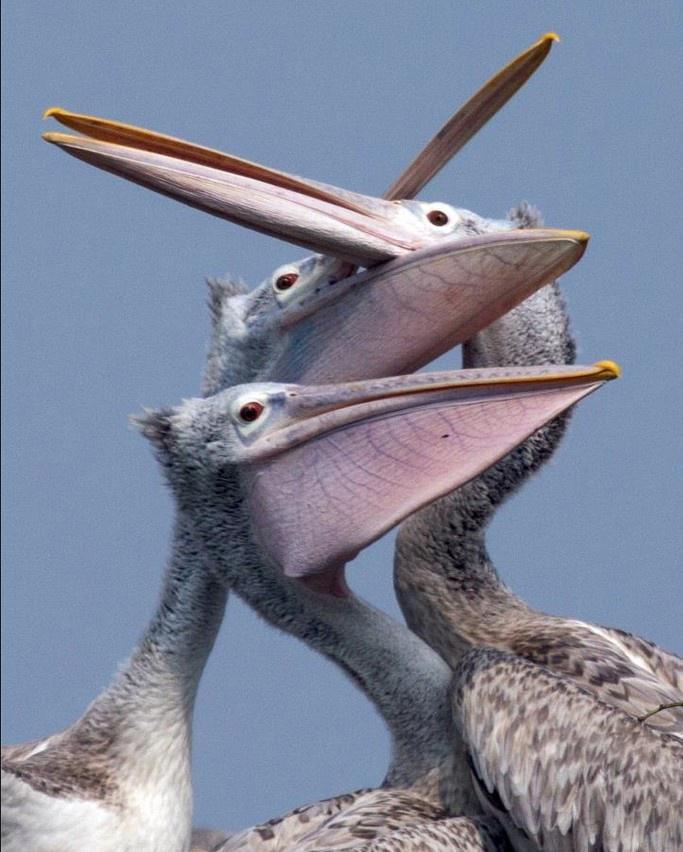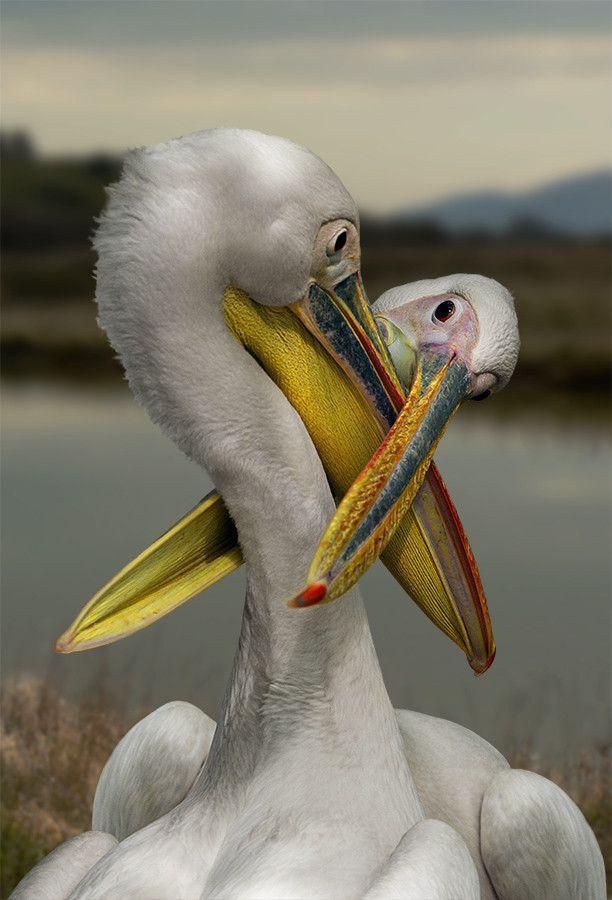The first image is the image on the left, the second image is the image on the right. Evaluate the accuracy of this statement regarding the images: "At least one image contains multiple pelicans in the foreground, and at least one image shows pelicans with their beaks crossed.". Is it true? Answer yes or no. Yes. The first image is the image on the left, the second image is the image on the right. Assess this claim about the two images: "There is at least two birds in the left image.". Correct or not? Answer yes or no. Yes. 